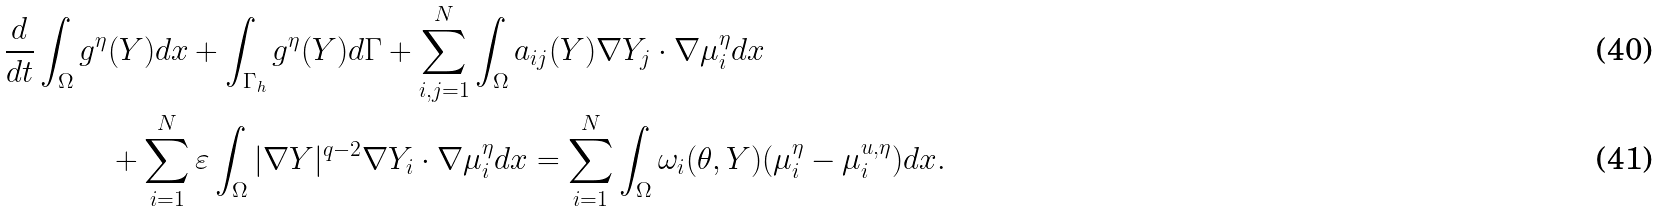Convert formula to latex. <formula><loc_0><loc_0><loc_500><loc_500>\frac { d } { d t } \int _ { \Omega } g ^ { \eta } & ( Y ) d x + \int _ { \Gamma _ { h } } g ^ { \eta } ( Y ) d \Gamma + \sum ^ { N } _ { i , j = 1 } \int _ { \Omega } a _ { i j } ( Y ) \nabla Y _ { j } \cdot \nabla \mu ^ { \eta } _ { i } d x \\ & + \sum ^ { N } _ { i = 1 } \varepsilon \int _ { \Omega } | \nabla Y | ^ { q - 2 } \nabla Y _ { i } \cdot \nabla \mu ^ { \eta } _ { i } d x = \sum ^ { N } _ { i = 1 } \int _ { \Omega } \omega _ { i } ( \theta , Y ) ( \mu ^ { \eta } _ { i } - \mu ^ { u , \eta } _ { i } ) d x .</formula> 